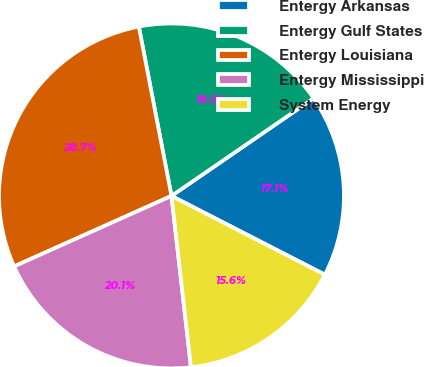Convert chart to OTSL. <chart><loc_0><loc_0><loc_500><loc_500><pie_chart><fcel>Entergy Arkansas<fcel>Entergy Gulf States<fcel>Entergy Louisiana<fcel>Entergy Mississippi<fcel>System Energy<nl><fcel>17.13%<fcel>18.45%<fcel>28.67%<fcel>20.1%<fcel>15.65%<nl></chart> 